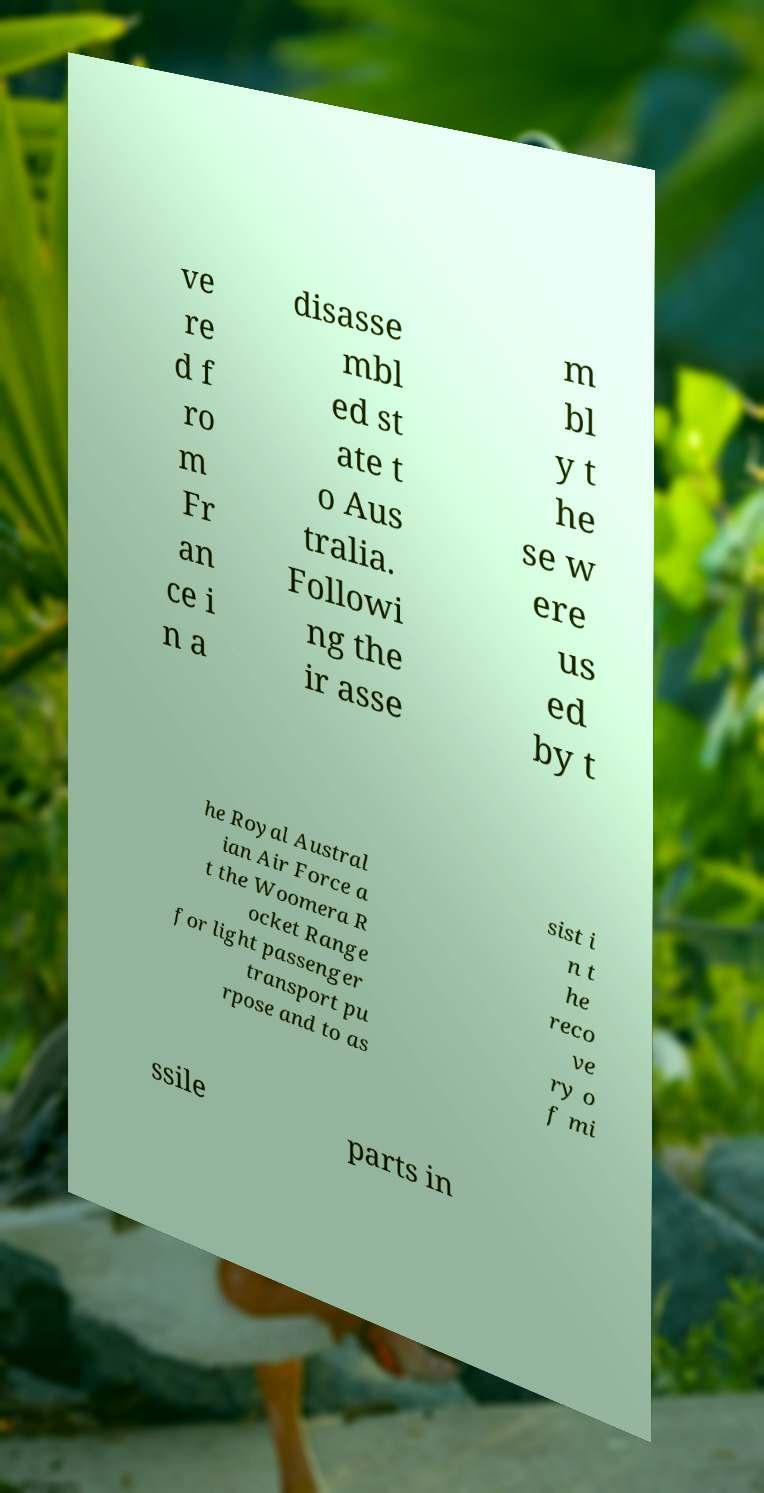Please read and relay the text visible in this image. What does it say? ve re d f ro m Fr an ce i n a disasse mbl ed st ate t o Aus tralia. Followi ng the ir asse m bl y t he se w ere us ed by t he Royal Austral ian Air Force a t the Woomera R ocket Range for light passenger transport pu rpose and to as sist i n t he reco ve ry o f mi ssile parts in 